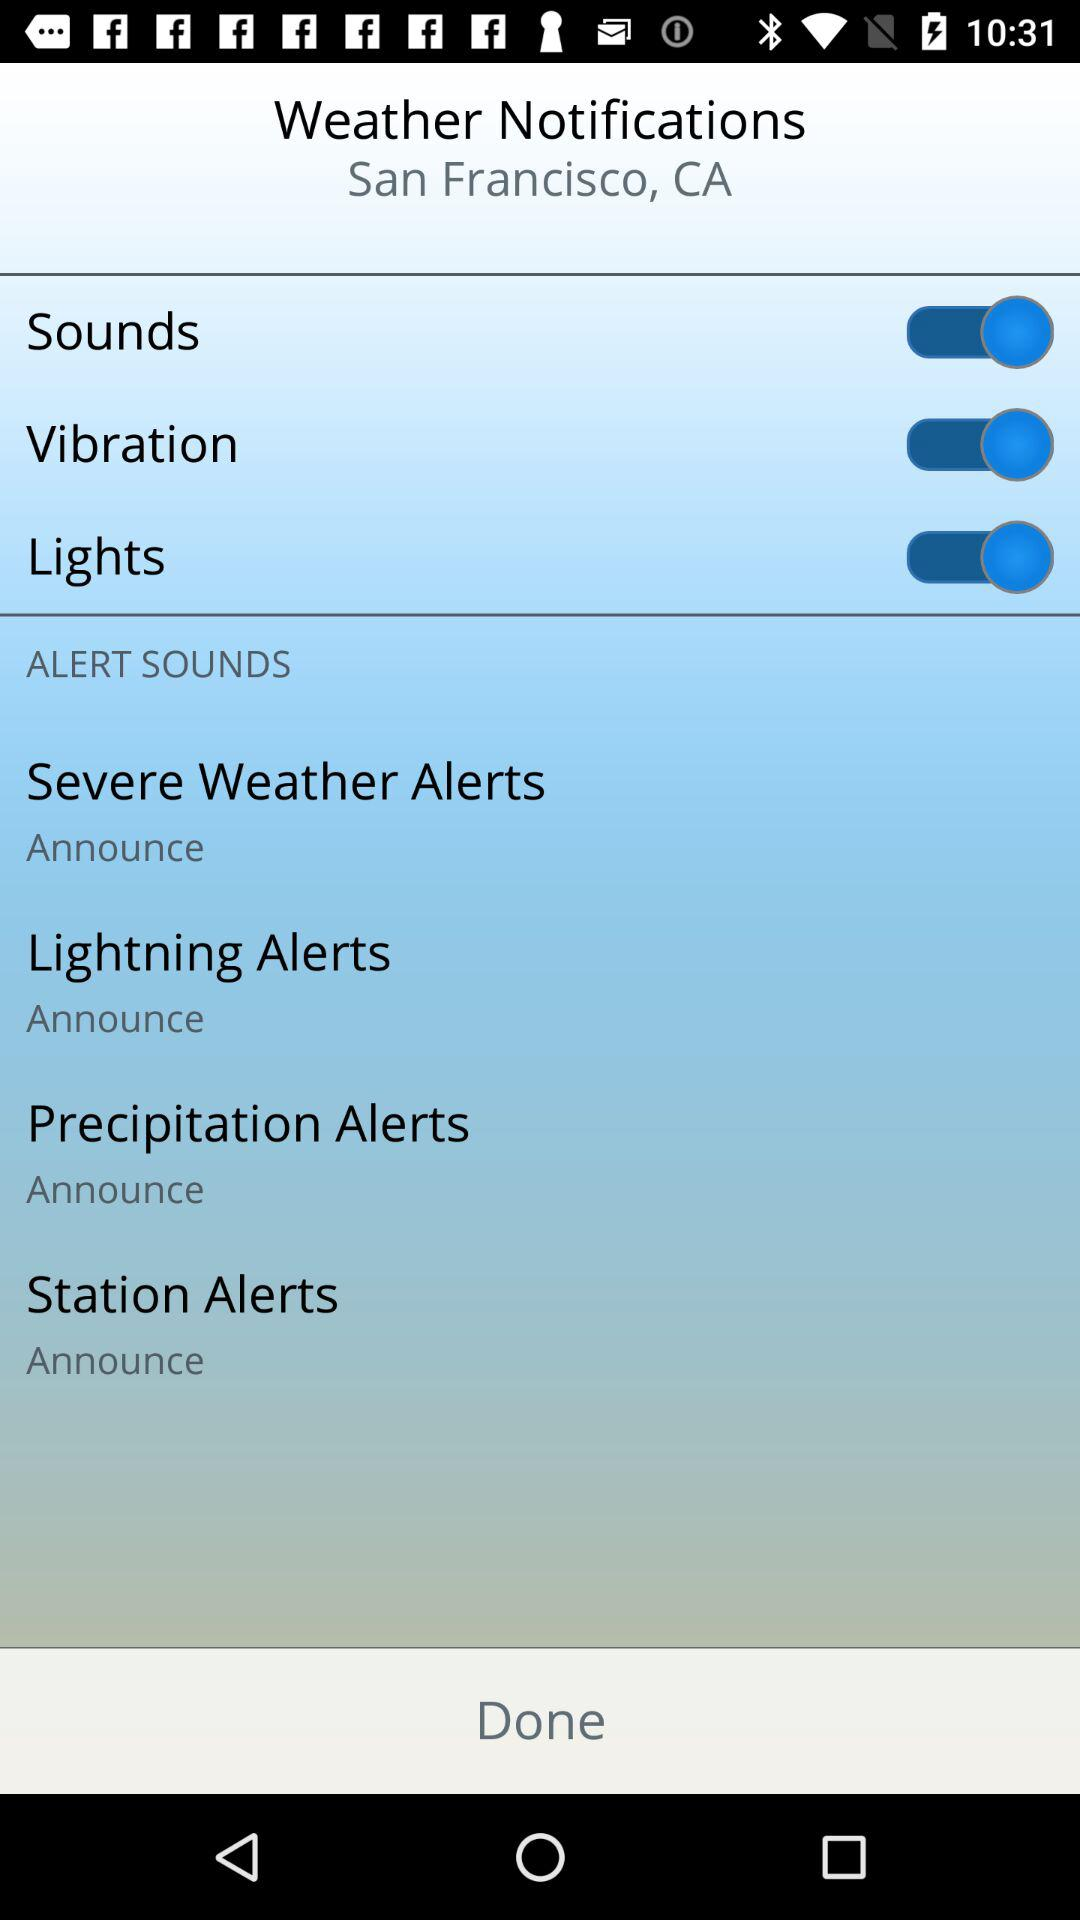What is the status of the "Lights"? The status is "on". 